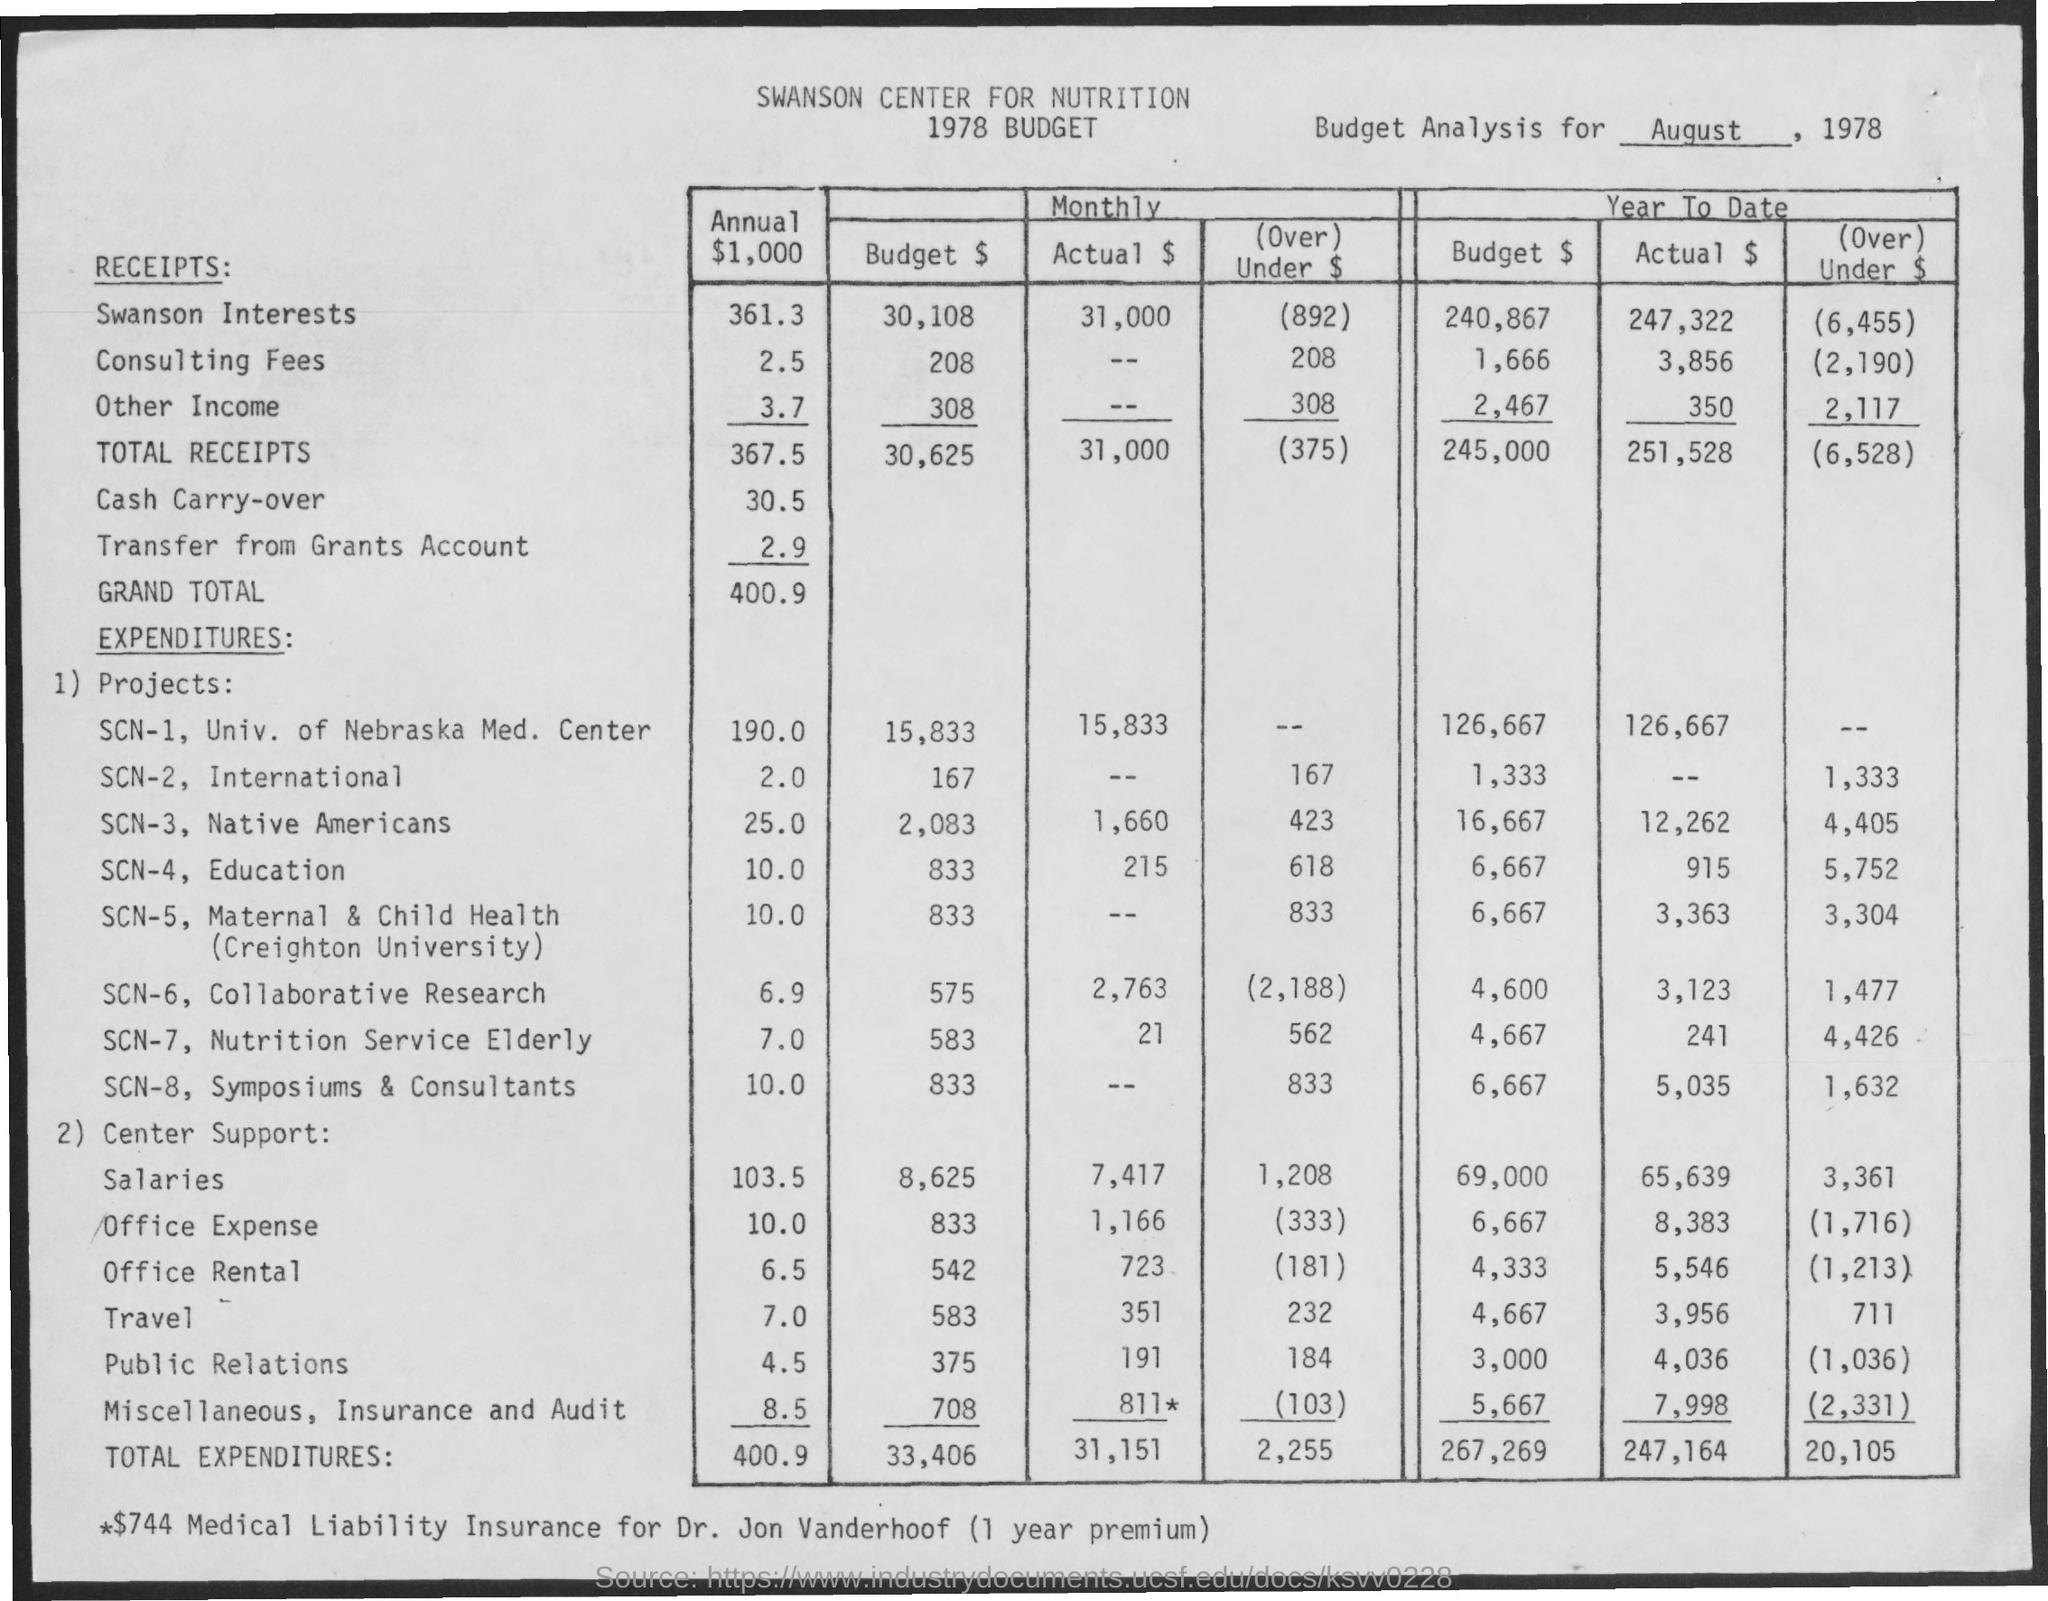Specify some key components in this picture. The actual amount of total expenditures per month is 31,151. The annual value of the total receipts mentioned is 367.5 cents. August 1978 is mentioned in the given page. The annual total expenditures are valued at 400.9. The annual grand total is 400.9. 